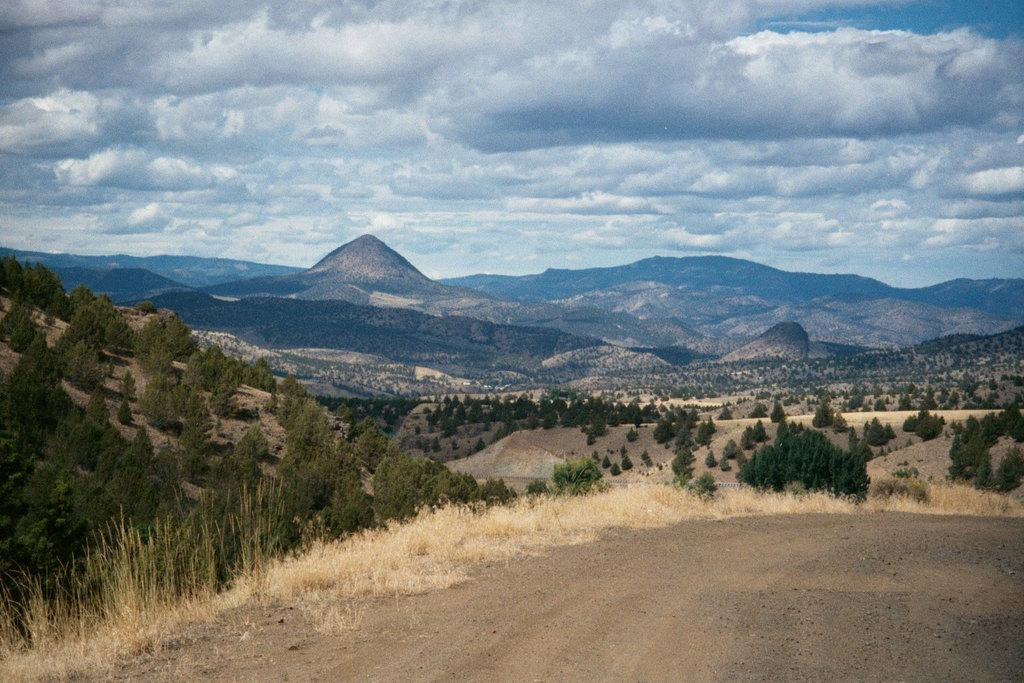What natural element can be seen in the image? The sky is visible in the image. What geographical feature is present in the image? There is a hill in the image. What type of vegetation is on the hill? Grass is present on the hill. What type of paste is being used to cover the hill in the image? There is no paste present in the image, and the hill is covered with grass. 